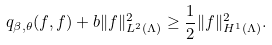<formula> <loc_0><loc_0><loc_500><loc_500>q _ { \beta , \theta } ( f , f ) + b \| f \| ^ { 2 } _ { L ^ { 2 } ( \Lambda ) } \geq \frac { 1 } { 2 } \| f \| ^ { 2 } _ { H ^ { 1 } ( \Lambda ) } .</formula> 